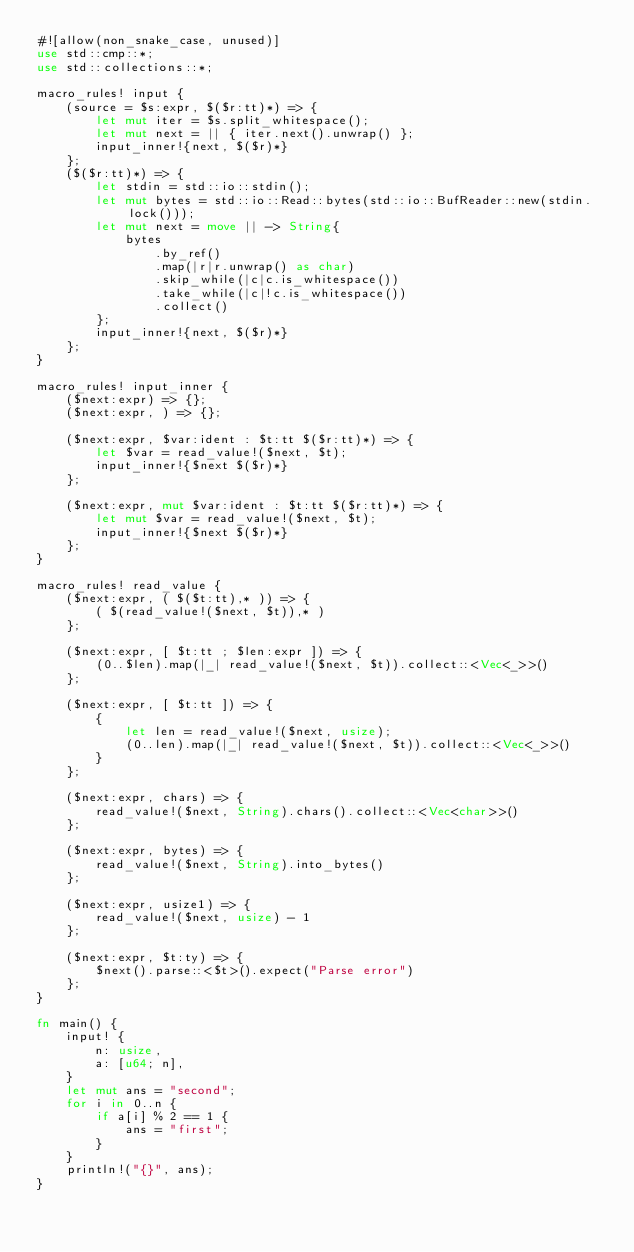<code> <loc_0><loc_0><loc_500><loc_500><_Rust_>#![allow(non_snake_case, unused)]
use std::cmp::*;
use std::collections::*;

macro_rules! input {
    (source = $s:expr, $($r:tt)*) => {
        let mut iter = $s.split_whitespace();
        let mut next = || { iter.next().unwrap() };
        input_inner!{next, $($r)*}
    };
    ($($r:tt)*) => {
        let stdin = std::io::stdin();
        let mut bytes = std::io::Read::bytes(std::io::BufReader::new(stdin.lock()));
        let mut next = move || -> String{
            bytes
                .by_ref()
                .map(|r|r.unwrap() as char)
                .skip_while(|c|c.is_whitespace())
                .take_while(|c|!c.is_whitespace())
                .collect()
        };
        input_inner!{next, $($r)*}
    };
}

macro_rules! input_inner {
    ($next:expr) => {};
    ($next:expr, ) => {};

    ($next:expr, $var:ident : $t:tt $($r:tt)*) => {
        let $var = read_value!($next, $t);
        input_inner!{$next $($r)*}
    };

    ($next:expr, mut $var:ident : $t:tt $($r:tt)*) => {
        let mut $var = read_value!($next, $t);
        input_inner!{$next $($r)*}
    };
}

macro_rules! read_value {
    ($next:expr, ( $($t:tt),* )) => {
        ( $(read_value!($next, $t)),* )
    };

    ($next:expr, [ $t:tt ; $len:expr ]) => {
        (0..$len).map(|_| read_value!($next, $t)).collect::<Vec<_>>()
    };

    ($next:expr, [ $t:tt ]) => {
        {
            let len = read_value!($next, usize);
            (0..len).map(|_| read_value!($next, $t)).collect::<Vec<_>>()
        }
    };

    ($next:expr, chars) => {
        read_value!($next, String).chars().collect::<Vec<char>>()
    };

    ($next:expr, bytes) => {
        read_value!($next, String).into_bytes()
    };

    ($next:expr, usize1) => {
        read_value!($next, usize) - 1
    };

    ($next:expr, $t:ty) => {
        $next().parse::<$t>().expect("Parse error")
    };
}

fn main() {
    input! {
        n: usize,
        a: [u64; n],
    }
    let mut ans = "second";
    for i in 0..n {
        if a[i] % 2 == 1 {
            ans = "first";
        }
    }
    println!("{}", ans);
}
</code> 